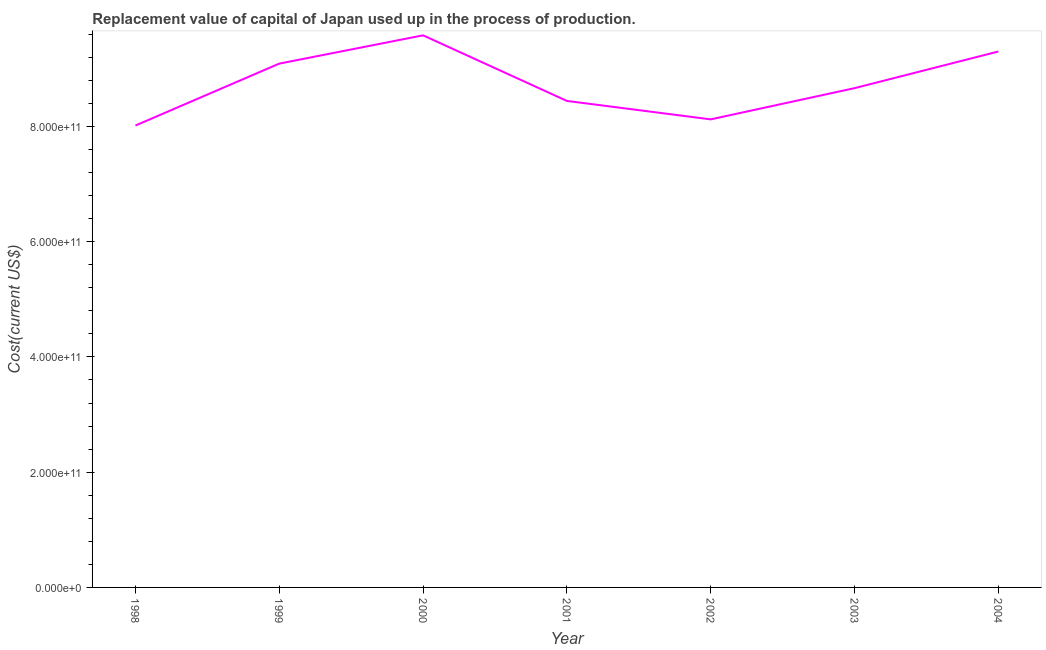What is the consumption of fixed capital in 2002?
Provide a succinct answer. 8.12e+11. Across all years, what is the maximum consumption of fixed capital?
Provide a succinct answer. 9.58e+11. Across all years, what is the minimum consumption of fixed capital?
Provide a short and direct response. 8.02e+11. In which year was the consumption of fixed capital maximum?
Your response must be concise. 2000. In which year was the consumption of fixed capital minimum?
Offer a very short reply. 1998. What is the sum of the consumption of fixed capital?
Your answer should be very brief. 6.12e+12. What is the difference between the consumption of fixed capital in 2001 and 2004?
Provide a short and direct response. -8.58e+1. What is the average consumption of fixed capital per year?
Ensure brevity in your answer.  8.75e+11. What is the median consumption of fixed capital?
Offer a very short reply. 8.66e+11. In how many years, is the consumption of fixed capital greater than 720000000000 US$?
Your answer should be compact. 7. What is the ratio of the consumption of fixed capital in 2000 to that in 2002?
Make the answer very short. 1.18. Is the difference between the consumption of fixed capital in 1998 and 2004 greater than the difference between any two years?
Keep it short and to the point. No. What is the difference between the highest and the second highest consumption of fixed capital?
Provide a short and direct response. 2.81e+1. What is the difference between the highest and the lowest consumption of fixed capital?
Provide a succinct answer. 1.57e+11. In how many years, is the consumption of fixed capital greater than the average consumption of fixed capital taken over all years?
Your answer should be compact. 3. How many lines are there?
Offer a very short reply. 1. What is the difference between two consecutive major ticks on the Y-axis?
Your response must be concise. 2.00e+11. Are the values on the major ticks of Y-axis written in scientific E-notation?
Keep it short and to the point. Yes. Does the graph contain any zero values?
Provide a succinct answer. No. What is the title of the graph?
Ensure brevity in your answer.  Replacement value of capital of Japan used up in the process of production. What is the label or title of the Y-axis?
Provide a succinct answer. Cost(current US$). What is the Cost(current US$) in 1998?
Offer a very short reply. 8.02e+11. What is the Cost(current US$) of 1999?
Make the answer very short. 9.09e+11. What is the Cost(current US$) of 2000?
Offer a very short reply. 9.58e+11. What is the Cost(current US$) of 2001?
Provide a short and direct response. 8.44e+11. What is the Cost(current US$) in 2002?
Your response must be concise. 8.12e+11. What is the Cost(current US$) of 2003?
Offer a very short reply. 8.66e+11. What is the Cost(current US$) of 2004?
Provide a short and direct response. 9.30e+11. What is the difference between the Cost(current US$) in 1998 and 1999?
Ensure brevity in your answer.  -1.07e+11. What is the difference between the Cost(current US$) in 1998 and 2000?
Ensure brevity in your answer.  -1.57e+11. What is the difference between the Cost(current US$) in 1998 and 2001?
Offer a very short reply. -4.27e+1. What is the difference between the Cost(current US$) in 1998 and 2002?
Provide a short and direct response. -1.07e+1. What is the difference between the Cost(current US$) in 1998 and 2003?
Offer a very short reply. -6.49e+1. What is the difference between the Cost(current US$) in 1998 and 2004?
Keep it short and to the point. -1.28e+11. What is the difference between the Cost(current US$) in 1999 and 2000?
Your response must be concise. -4.91e+1. What is the difference between the Cost(current US$) in 1999 and 2001?
Make the answer very short. 6.47e+1. What is the difference between the Cost(current US$) in 1999 and 2002?
Your answer should be compact. 9.67e+1. What is the difference between the Cost(current US$) in 1999 and 2003?
Offer a very short reply. 4.26e+1. What is the difference between the Cost(current US$) in 1999 and 2004?
Your answer should be compact. -2.10e+1. What is the difference between the Cost(current US$) in 2000 and 2001?
Make the answer very short. 1.14e+11. What is the difference between the Cost(current US$) in 2000 and 2002?
Give a very brief answer. 1.46e+11. What is the difference between the Cost(current US$) in 2000 and 2003?
Ensure brevity in your answer.  9.17e+1. What is the difference between the Cost(current US$) in 2000 and 2004?
Offer a very short reply. 2.81e+1. What is the difference between the Cost(current US$) in 2001 and 2002?
Provide a short and direct response. 3.20e+1. What is the difference between the Cost(current US$) in 2001 and 2003?
Your response must be concise. -2.22e+1. What is the difference between the Cost(current US$) in 2001 and 2004?
Keep it short and to the point. -8.58e+1. What is the difference between the Cost(current US$) in 2002 and 2003?
Make the answer very short. -5.42e+1. What is the difference between the Cost(current US$) in 2002 and 2004?
Give a very brief answer. -1.18e+11. What is the difference between the Cost(current US$) in 2003 and 2004?
Your answer should be very brief. -6.36e+1. What is the ratio of the Cost(current US$) in 1998 to that in 1999?
Make the answer very short. 0.88. What is the ratio of the Cost(current US$) in 1998 to that in 2000?
Your response must be concise. 0.84. What is the ratio of the Cost(current US$) in 1998 to that in 2001?
Make the answer very short. 0.95. What is the ratio of the Cost(current US$) in 1998 to that in 2003?
Keep it short and to the point. 0.93. What is the ratio of the Cost(current US$) in 1998 to that in 2004?
Keep it short and to the point. 0.86. What is the ratio of the Cost(current US$) in 1999 to that in 2000?
Provide a short and direct response. 0.95. What is the ratio of the Cost(current US$) in 1999 to that in 2001?
Offer a terse response. 1.08. What is the ratio of the Cost(current US$) in 1999 to that in 2002?
Offer a terse response. 1.12. What is the ratio of the Cost(current US$) in 1999 to that in 2003?
Your answer should be very brief. 1.05. What is the ratio of the Cost(current US$) in 2000 to that in 2001?
Give a very brief answer. 1.14. What is the ratio of the Cost(current US$) in 2000 to that in 2002?
Ensure brevity in your answer.  1.18. What is the ratio of the Cost(current US$) in 2000 to that in 2003?
Offer a very short reply. 1.11. What is the ratio of the Cost(current US$) in 2000 to that in 2004?
Give a very brief answer. 1.03. What is the ratio of the Cost(current US$) in 2001 to that in 2002?
Make the answer very short. 1.04. What is the ratio of the Cost(current US$) in 2001 to that in 2004?
Your answer should be compact. 0.91. What is the ratio of the Cost(current US$) in 2002 to that in 2003?
Keep it short and to the point. 0.94. What is the ratio of the Cost(current US$) in 2002 to that in 2004?
Your answer should be very brief. 0.87. What is the ratio of the Cost(current US$) in 2003 to that in 2004?
Ensure brevity in your answer.  0.93. 